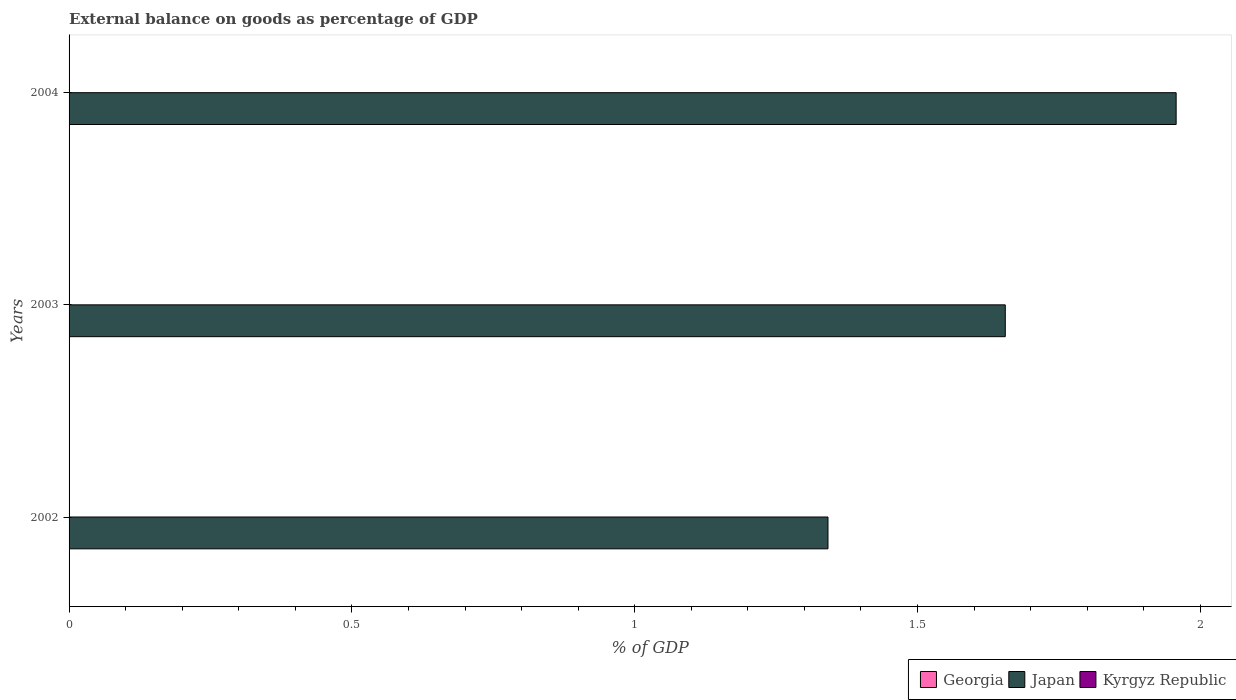Are the number of bars on each tick of the Y-axis equal?
Your response must be concise. Yes. How many bars are there on the 2nd tick from the bottom?
Offer a terse response. 1. What is the label of the 1st group of bars from the top?
Your response must be concise. 2004. What is the external balance on goods as percentage of GDP in Georgia in 2004?
Give a very brief answer. 0. Across all years, what is the maximum external balance on goods as percentage of GDP in Japan?
Your response must be concise. 1.96. Across all years, what is the minimum external balance on goods as percentage of GDP in Georgia?
Your answer should be compact. 0. What is the difference between the external balance on goods as percentage of GDP in Japan in 2002 and that in 2003?
Offer a very short reply. -0.31. In how many years, is the external balance on goods as percentage of GDP in Georgia greater than 0.2 %?
Ensure brevity in your answer.  0. What is the ratio of the external balance on goods as percentage of GDP in Japan in 2002 to that in 2004?
Provide a succinct answer. 0.69. Is the external balance on goods as percentage of GDP in Japan in 2003 less than that in 2004?
Give a very brief answer. Yes. What is the difference between the highest and the lowest external balance on goods as percentage of GDP in Japan?
Offer a very short reply. 0.62. In how many years, is the external balance on goods as percentage of GDP in Japan greater than the average external balance on goods as percentage of GDP in Japan taken over all years?
Provide a short and direct response. 2. How many bars are there?
Offer a terse response. 3. How many years are there in the graph?
Make the answer very short. 3. Are the values on the major ticks of X-axis written in scientific E-notation?
Offer a terse response. No. Does the graph contain any zero values?
Your answer should be compact. Yes. How many legend labels are there?
Make the answer very short. 3. What is the title of the graph?
Ensure brevity in your answer.  External balance on goods as percentage of GDP. Does "Iraq" appear as one of the legend labels in the graph?
Provide a short and direct response. No. What is the label or title of the X-axis?
Your answer should be compact. % of GDP. What is the label or title of the Y-axis?
Keep it short and to the point. Years. What is the % of GDP of Georgia in 2002?
Your response must be concise. 0. What is the % of GDP of Japan in 2002?
Keep it short and to the point. 1.34. What is the % of GDP of Georgia in 2003?
Provide a succinct answer. 0. What is the % of GDP of Japan in 2003?
Offer a very short reply. 1.66. What is the % of GDP of Japan in 2004?
Provide a short and direct response. 1.96. Across all years, what is the maximum % of GDP in Japan?
Give a very brief answer. 1.96. Across all years, what is the minimum % of GDP of Japan?
Your answer should be compact. 1.34. What is the total % of GDP in Japan in the graph?
Provide a short and direct response. 4.95. What is the difference between the % of GDP of Japan in 2002 and that in 2003?
Make the answer very short. -0.31. What is the difference between the % of GDP of Japan in 2002 and that in 2004?
Offer a very short reply. -0.62. What is the difference between the % of GDP in Japan in 2003 and that in 2004?
Your answer should be compact. -0.3. What is the average % of GDP in Georgia per year?
Keep it short and to the point. 0. What is the average % of GDP in Japan per year?
Provide a succinct answer. 1.65. What is the ratio of the % of GDP in Japan in 2002 to that in 2003?
Give a very brief answer. 0.81. What is the ratio of the % of GDP of Japan in 2002 to that in 2004?
Your answer should be very brief. 0.69. What is the ratio of the % of GDP of Japan in 2003 to that in 2004?
Keep it short and to the point. 0.85. What is the difference between the highest and the second highest % of GDP of Japan?
Your response must be concise. 0.3. What is the difference between the highest and the lowest % of GDP of Japan?
Your response must be concise. 0.62. 